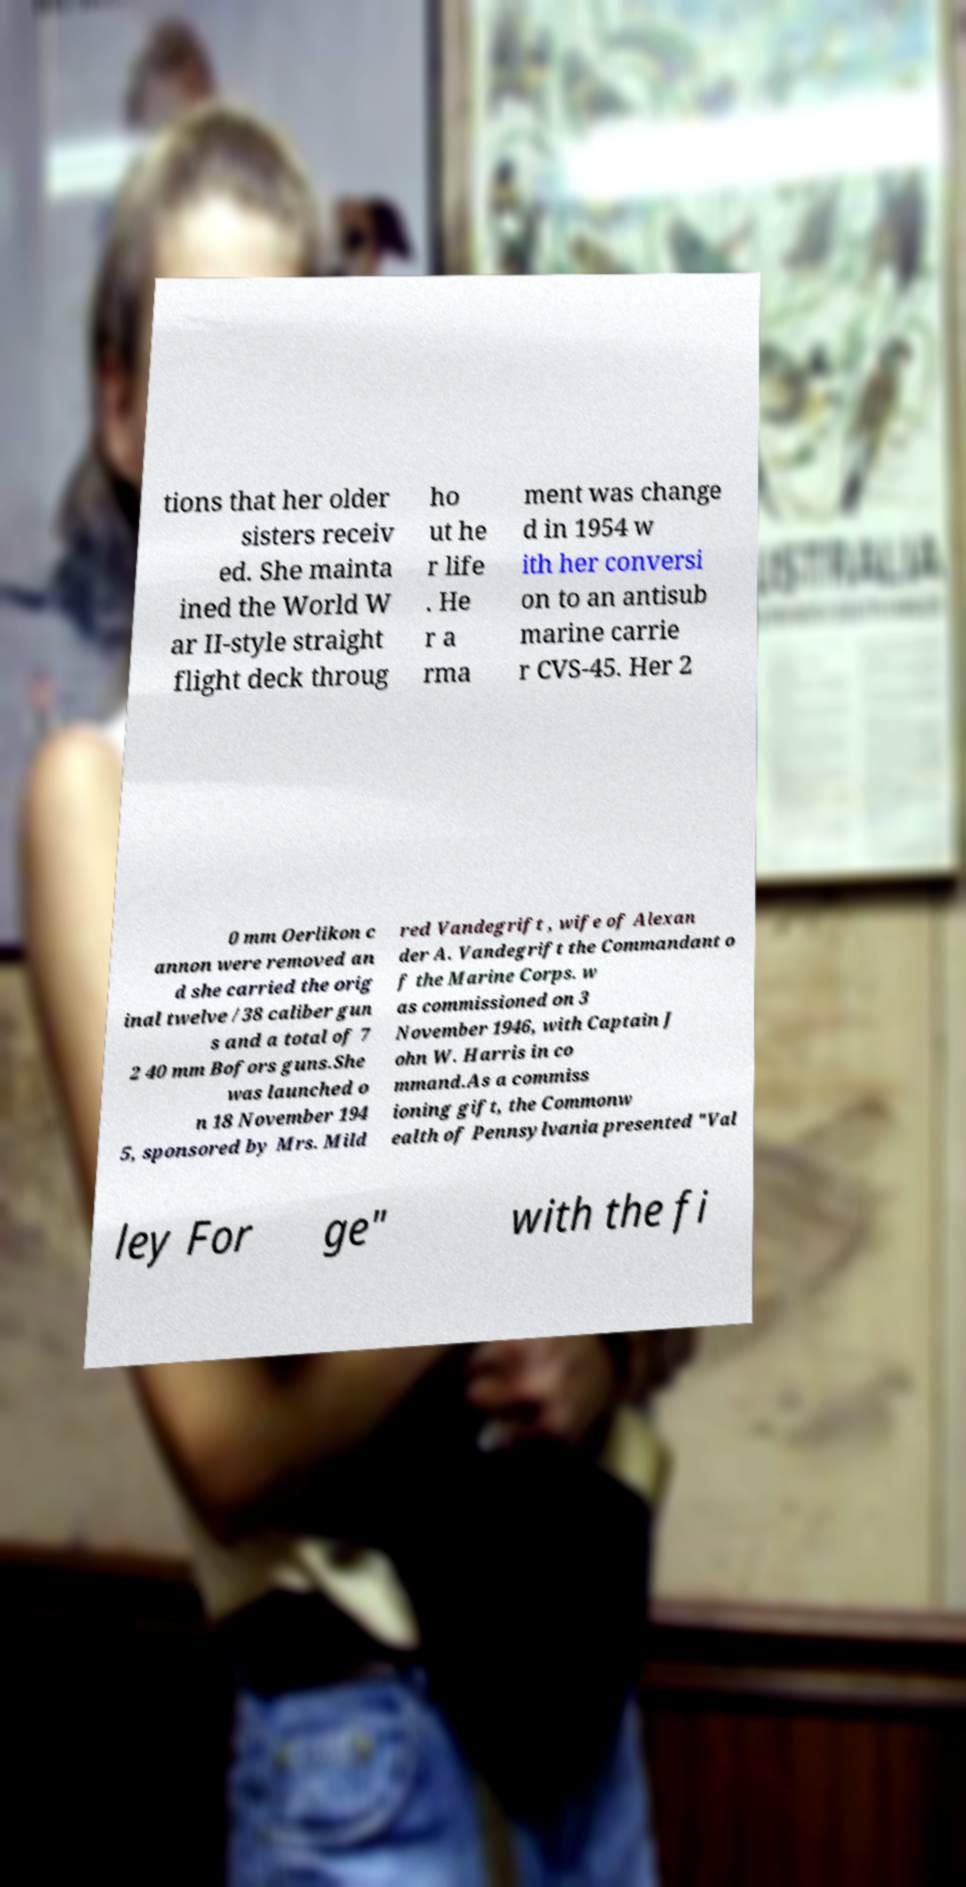Please read and relay the text visible in this image. What does it say? tions that her older sisters receiv ed. She mainta ined the World W ar II-style straight flight deck throug ho ut he r life . He r a rma ment was change d in 1954 w ith her conversi on to an antisub marine carrie r CVS-45. Her 2 0 mm Oerlikon c annon were removed an d she carried the orig inal twelve /38 caliber gun s and a total of 7 2 40 mm Bofors guns.She was launched o n 18 November 194 5, sponsored by Mrs. Mild red Vandegrift , wife of Alexan der A. Vandegrift the Commandant o f the Marine Corps. w as commissioned on 3 November 1946, with Captain J ohn W. Harris in co mmand.As a commiss ioning gift, the Commonw ealth of Pennsylvania presented "Val ley For ge" with the fi 